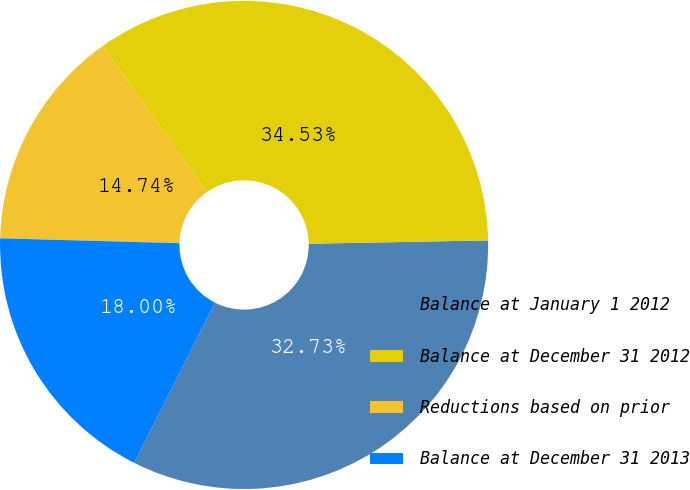Convert chart to OTSL. <chart><loc_0><loc_0><loc_500><loc_500><pie_chart><fcel>Balance at January 1 2012<fcel>Balance at December 31 2012<fcel>Reductions based on prior<fcel>Balance at December 31 2013<nl><fcel>32.73%<fcel>34.53%<fcel>14.74%<fcel>18.0%<nl></chart> 